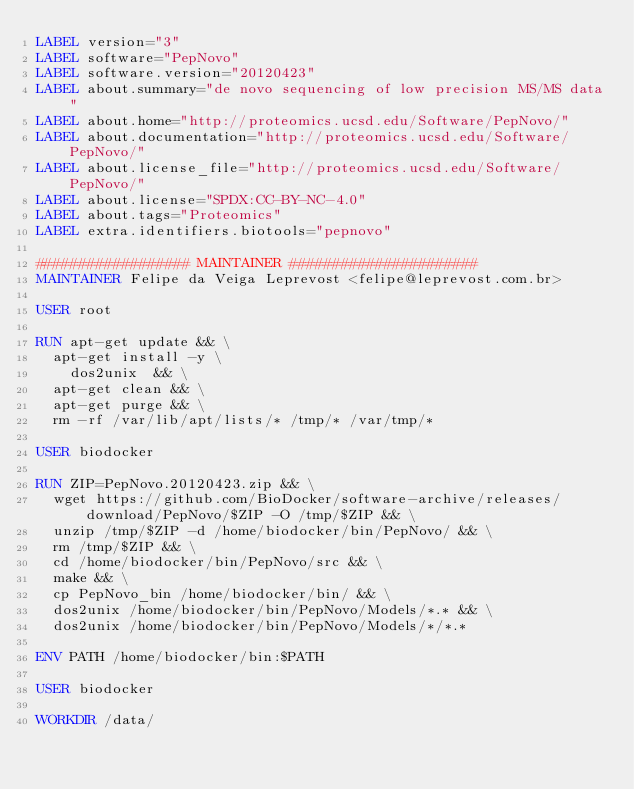<code> <loc_0><loc_0><loc_500><loc_500><_Dockerfile_>LABEL version="3"
LABEL software="PepNovo"
LABEL software.version="20120423"
LABEL about.summary="de novo sequencing of low precision MS/MS data"
LABEL about.home="http://proteomics.ucsd.edu/Software/PepNovo/"
LABEL about.documentation="http://proteomics.ucsd.edu/Software/PepNovo/"
LABEL about.license_file="http://proteomics.ucsd.edu/Software/PepNovo/"
LABEL about.license="SPDX:CC-BY-NC-4.0"
LABEL about.tags="Proteomics"
LABEL extra.identifiers.biotools="pepnovo"

################## MAINTAINER ######################
MAINTAINER Felipe da Veiga Leprevost <felipe@leprevost.com.br>

USER root

RUN apt-get update && \
  apt-get install -y \
	dos2unix  && \
  apt-get clean && \
  apt-get purge && \
  rm -rf /var/lib/apt/lists/* /tmp/* /var/tmp/*

USER biodocker

RUN ZIP=PepNovo.20120423.zip && \
  wget https://github.com/BioDocker/software-archive/releases/download/PepNovo/$ZIP -O /tmp/$ZIP && \
  unzip /tmp/$ZIP -d /home/biodocker/bin/PepNovo/ && \
  rm /tmp/$ZIP && \
  cd /home/biodocker/bin/PepNovo/src && \
  make && \
  cp PepNovo_bin /home/biodocker/bin/ && \
  dos2unix /home/biodocker/bin/PepNovo/Models/*.* && \
  dos2unix /home/biodocker/bin/PepNovo/Models/*/*.*

ENV PATH /home/biodocker/bin:$PATH

USER biodocker

WORKDIR /data/
</code> 